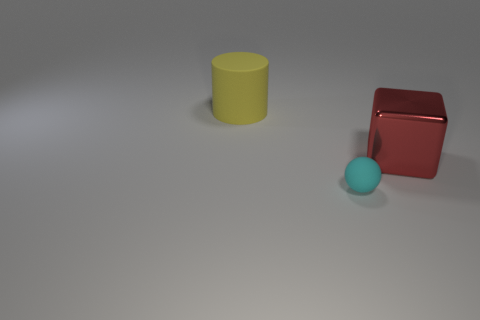Add 2 rubber spheres. How many objects exist? 5 Subtract all blocks. How many objects are left? 2 Subtract all big green metallic objects. Subtract all shiny blocks. How many objects are left? 2 Add 1 large shiny blocks. How many large shiny blocks are left? 2 Add 3 cyan matte blocks. How many cyan matte blocks exist? 3 Subtract 0 blue balls. How many objects are left? 3 